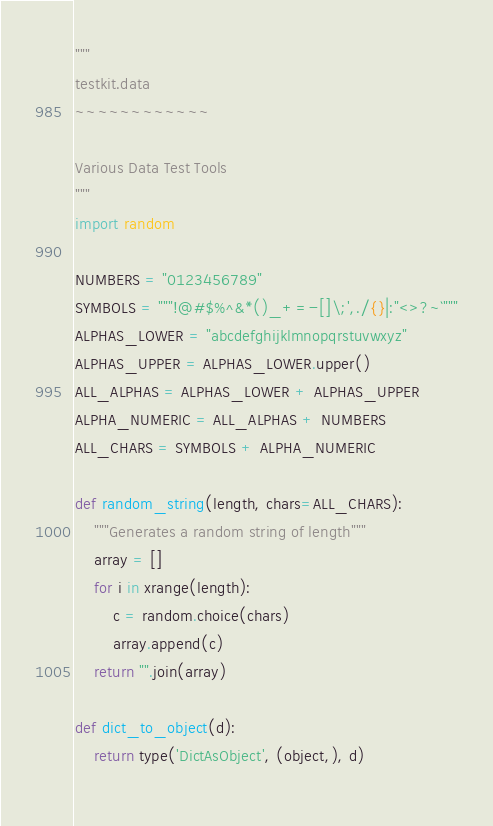Convert code to text. <code><loc_0><loc_0><loc_500><loc_500><_Python_>"""
testkit.data
~~~~~~~~~~~~

Various Data Test Tools
"""
import random

NUMBERS = "0123456789"
SYMBOLS = """!@#$%^&*()_+=-[]\;',./{}|:"<>?~`"""
ALPHAS_LOWER = "abcdefghijklmnopqrstuvwxyz"
ALPHAS_UPPER = ALPHAS_LOWER.upper()
ALL_ALPHAS = ALPHAS_LOWER + ALPHAS_UPPER
ALPHA_NUMERIC = ALL_ALPHAS + NUMBERS
ALL_CHARS = SYMBOLS + ALPHA_NUMERIC

def random_string(length, chars=ALL_CHARS):
    """Generates a random string of length"""
    array = []
    for i in xrange(length):
        c = random.choice(chars)
        array.append(c)
    return "".join(array)

def dict_to_object(d):
    return type('DictAsObject', (object,), d)
    
</code> 